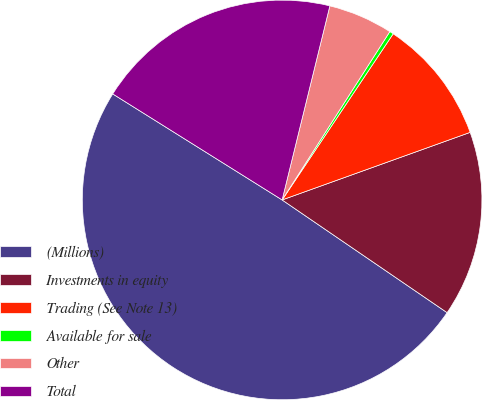Convert chart. <chart><loc_0><loc_0><loc_500><loc_500><pie_chart><fcel>(Millions)<fcel>Investments in equity<fcel>Trading (See Note 13)<fcel>Available for sale<fcel>Other<fcel>Total<nl><fcel>49.36%<fcel>15.03%<fcel>10.13%<fcel>0.32%<fcel>5.22%<fcel>19.94%<nl></chart> 